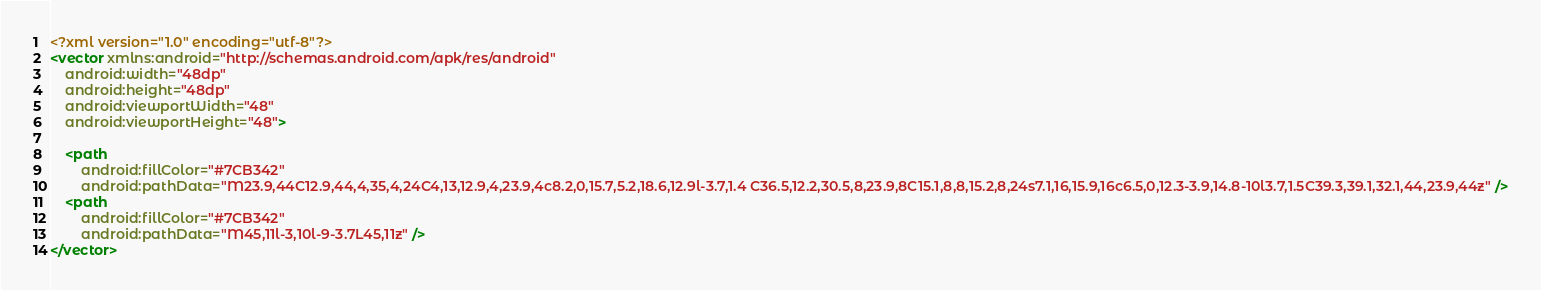<code> <loc_0><loc_0><loc_500><loc_500><_XML_><?xml version="1.0" encoding="utf-8"?>
<vector xmlns:android="http://schemas.android.com/apk/res/android"
    android:width="48dp"
    android:height="48dp"
    android:viewportWidth="48"
    android:viewportHeight="48">

    <path
        android:fillColor="#7CB342"
        android:pathData="M23.9,44C12.9,44,4,35,4,24C4,13,12.9,4,23.9,4c8.2,0,15.7,5.2,18.6,12.9l-3.7,1.4 C36.5,12.2,30.5,8,23.9,8C15.1,8,8,15.2,8,24s7.1,16,15.9,16c6.5,0,12.3-3.9,14.8-10l3.7,1.5C39.3,39.1,32.1,44,23.9,44z" />
    <path
        android:fillColor="#7CB342"
        android:pathData="M45,11l-3,10l-9-3.7L45,11z" />
</vector></code> 